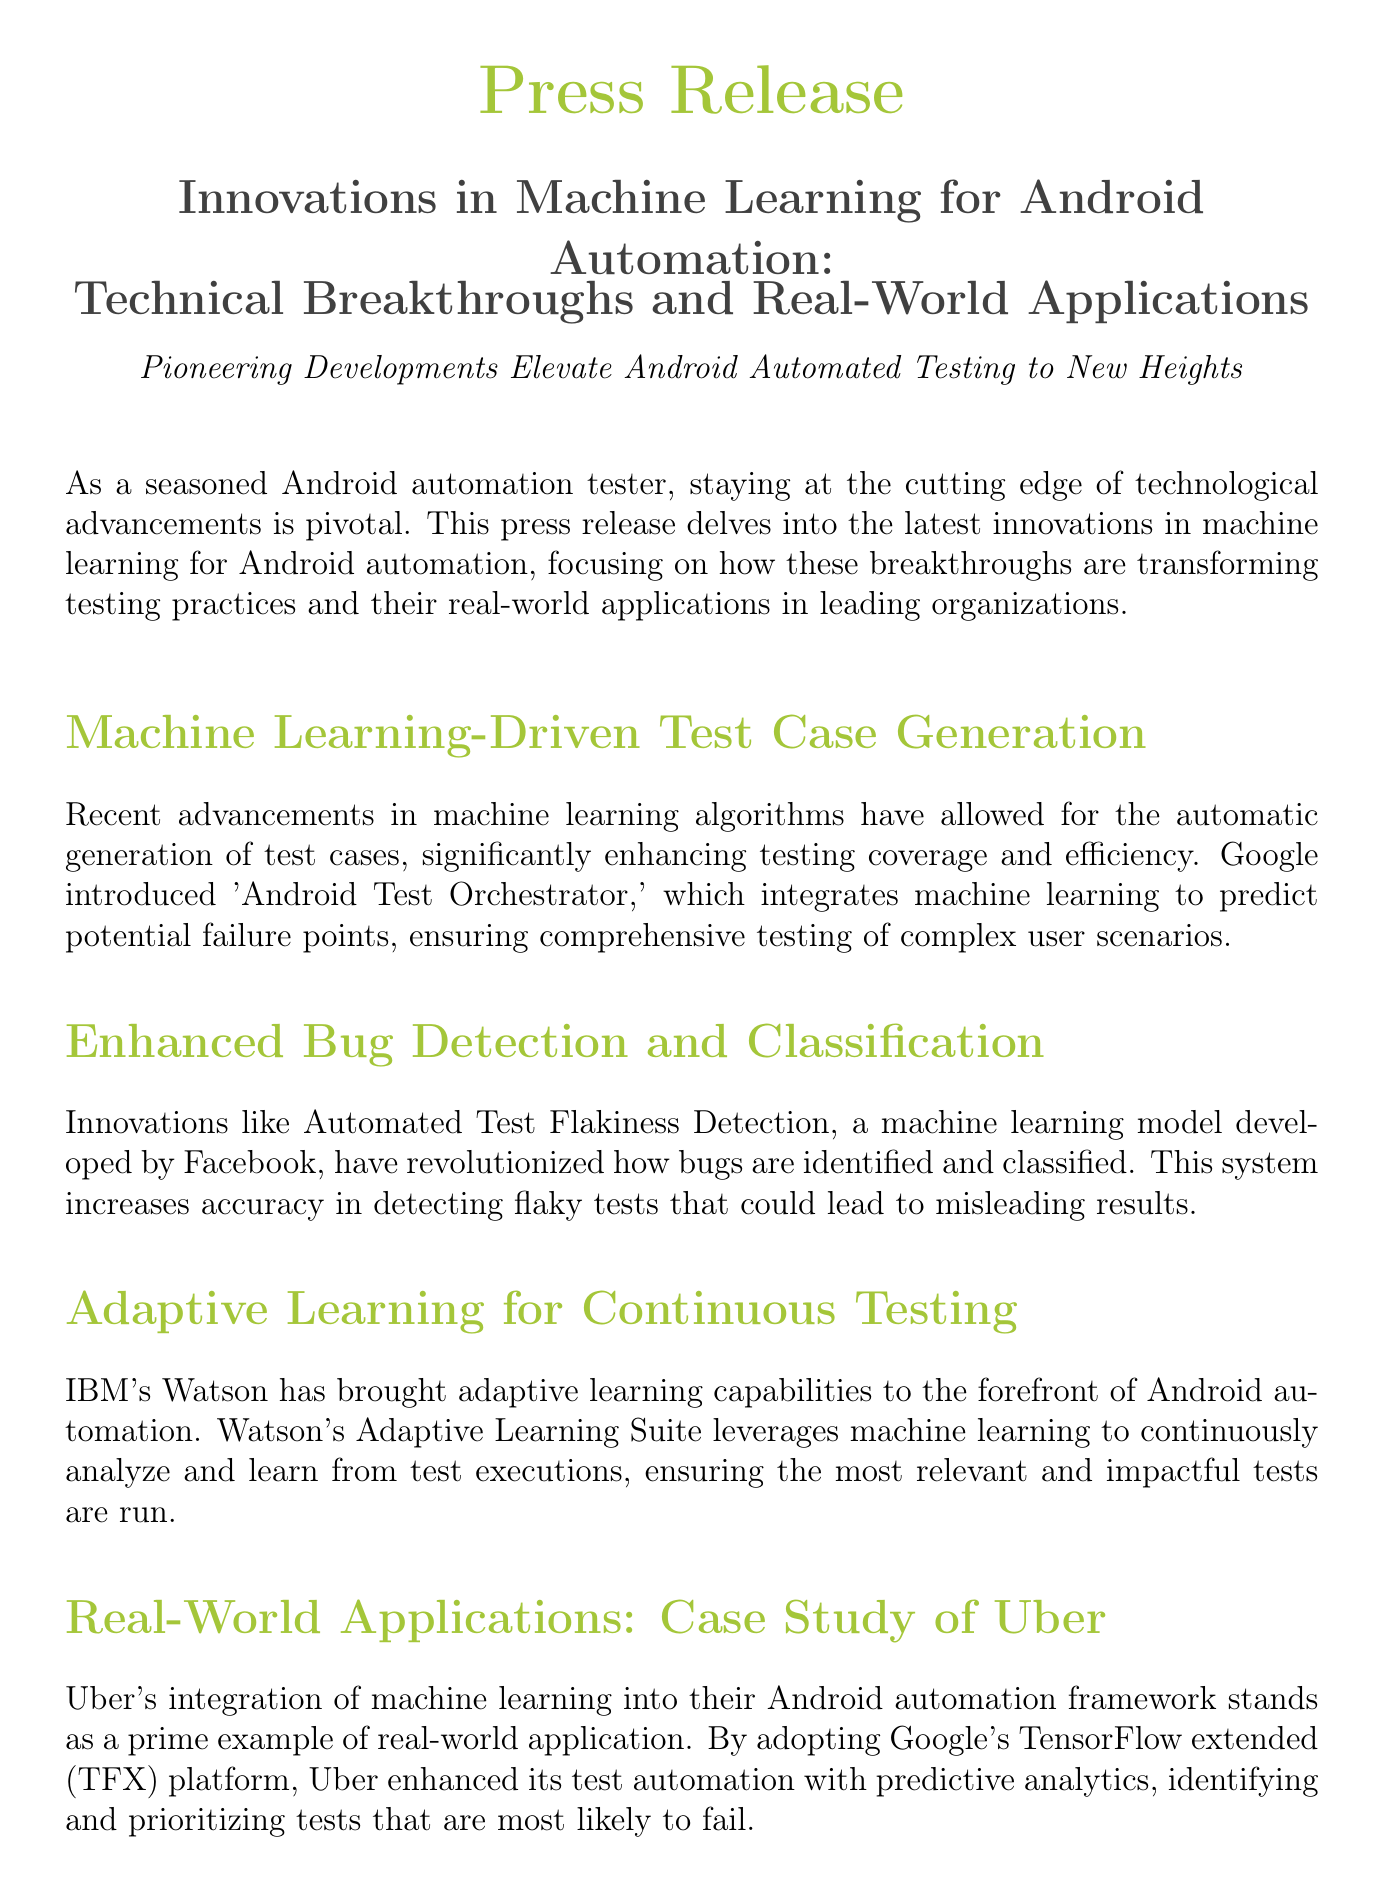What is the title of the press release? The title of the press release is explicitly mentioned in the document as "Innovations in Machine Learning for Android Automation: Technical Breakthroughs and Real-World Applications."
Answer: Innovations in Machine Learning for Android Automation: Technical Breakthroughs and Real-World Applications Who is the contact person mentioned in the press release? The document lists John Doe as the contact person for inquiries in the press release.
Answer: John Doe What machine learning model was developed by Facebook? The press release specifies the "Automated Test Flakiness Detection" as the machine learning model developed by Facebook.
Answer: Automated Test Flakiness Detection What is the name of IBM's adaptive learning suite? IBM's adaptive learning capabilities are referred to as "Watson's Adaptive Learning Suite" within the document.
Answer: Watson's Adaptive Learning Suite What platform did Uber adopt for its automation? Uber's automation framework integrates the "Google's TensorFlow extended (TFX) platform," as mentioned in the case study.
Answer: Google's TensorFlow extended (TFX) platform What key technology is anticipated for future debugging tools? The press release indicates that "AI-augmented debugging tools" are the expected future technology in Android automation testing.
Answer: AI-augmented debugging tools How does the document describe the impact of machine learning on Android automation testing? The document states that the convergence of machine learning with Android automation testing marks a significant milestone in QA practices.
Answer: Significant milestone What is the role of predictive analytics in Uber's testing framework? The press release highlights that predictive analytics helps identify and prioritize tests that are most likely to fail in Uber's testing framework.
Answer: Identify and prioritize tests What are the expected benefits of embracing these innovations for testers? The document explains that embracing these innovations is essential for keeping pace with the rapidly evolving tech landscape for automation testers.
Answer: Keeping pace with the rapidly evolving tech landscape 